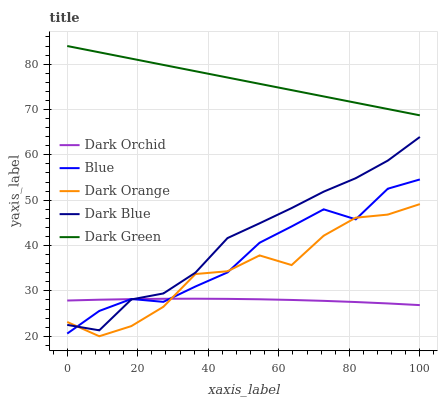Does Dark Orchid have the minimum area under the curve?
Answer yes or no. Yes. Does Dark Green have the maximum area under the curve?
Answer yes or no. Yes. Does Dark Orange have the minimum area under the curve?
Answer yes or no. No. Does Dark Orange have the maximum area under the curve?
Answer yes or no. No. Is Dark Green the smoothest?
Answer yes or no. Yes. Is Dark Orange the roughest?
Answer yes or no. Yes. Is Dark Orange the smoothest?
Answer yes or no. No. Is Dark Green the roughest?
Answer yes or no. No. Does Dark Orange have the lowest value?
Answer yes or no. Yes. Does Dark Green have the lowest value?
Answer yes or no. No. Does Dark Green have the highest value?
Answer yes or no. Yes. Does Dark Orange have the highest value?
Answer yes or no. No. Is Dark Orange less than Dark Green?
Answer yes or no. Yes. Is Dark Green greater than Dark Blue?
Answer yes or no. Yes. Does Blue intersect Dark Blue?
Answer yes or no. Yes. Is Blue less than Dark Blue?
Answer yes or no. No. Is Blue greater than Dark Blue?
Answer yes or no. No. Does Dark Orange intersect Dark Green?
Answer yes or no. No. 